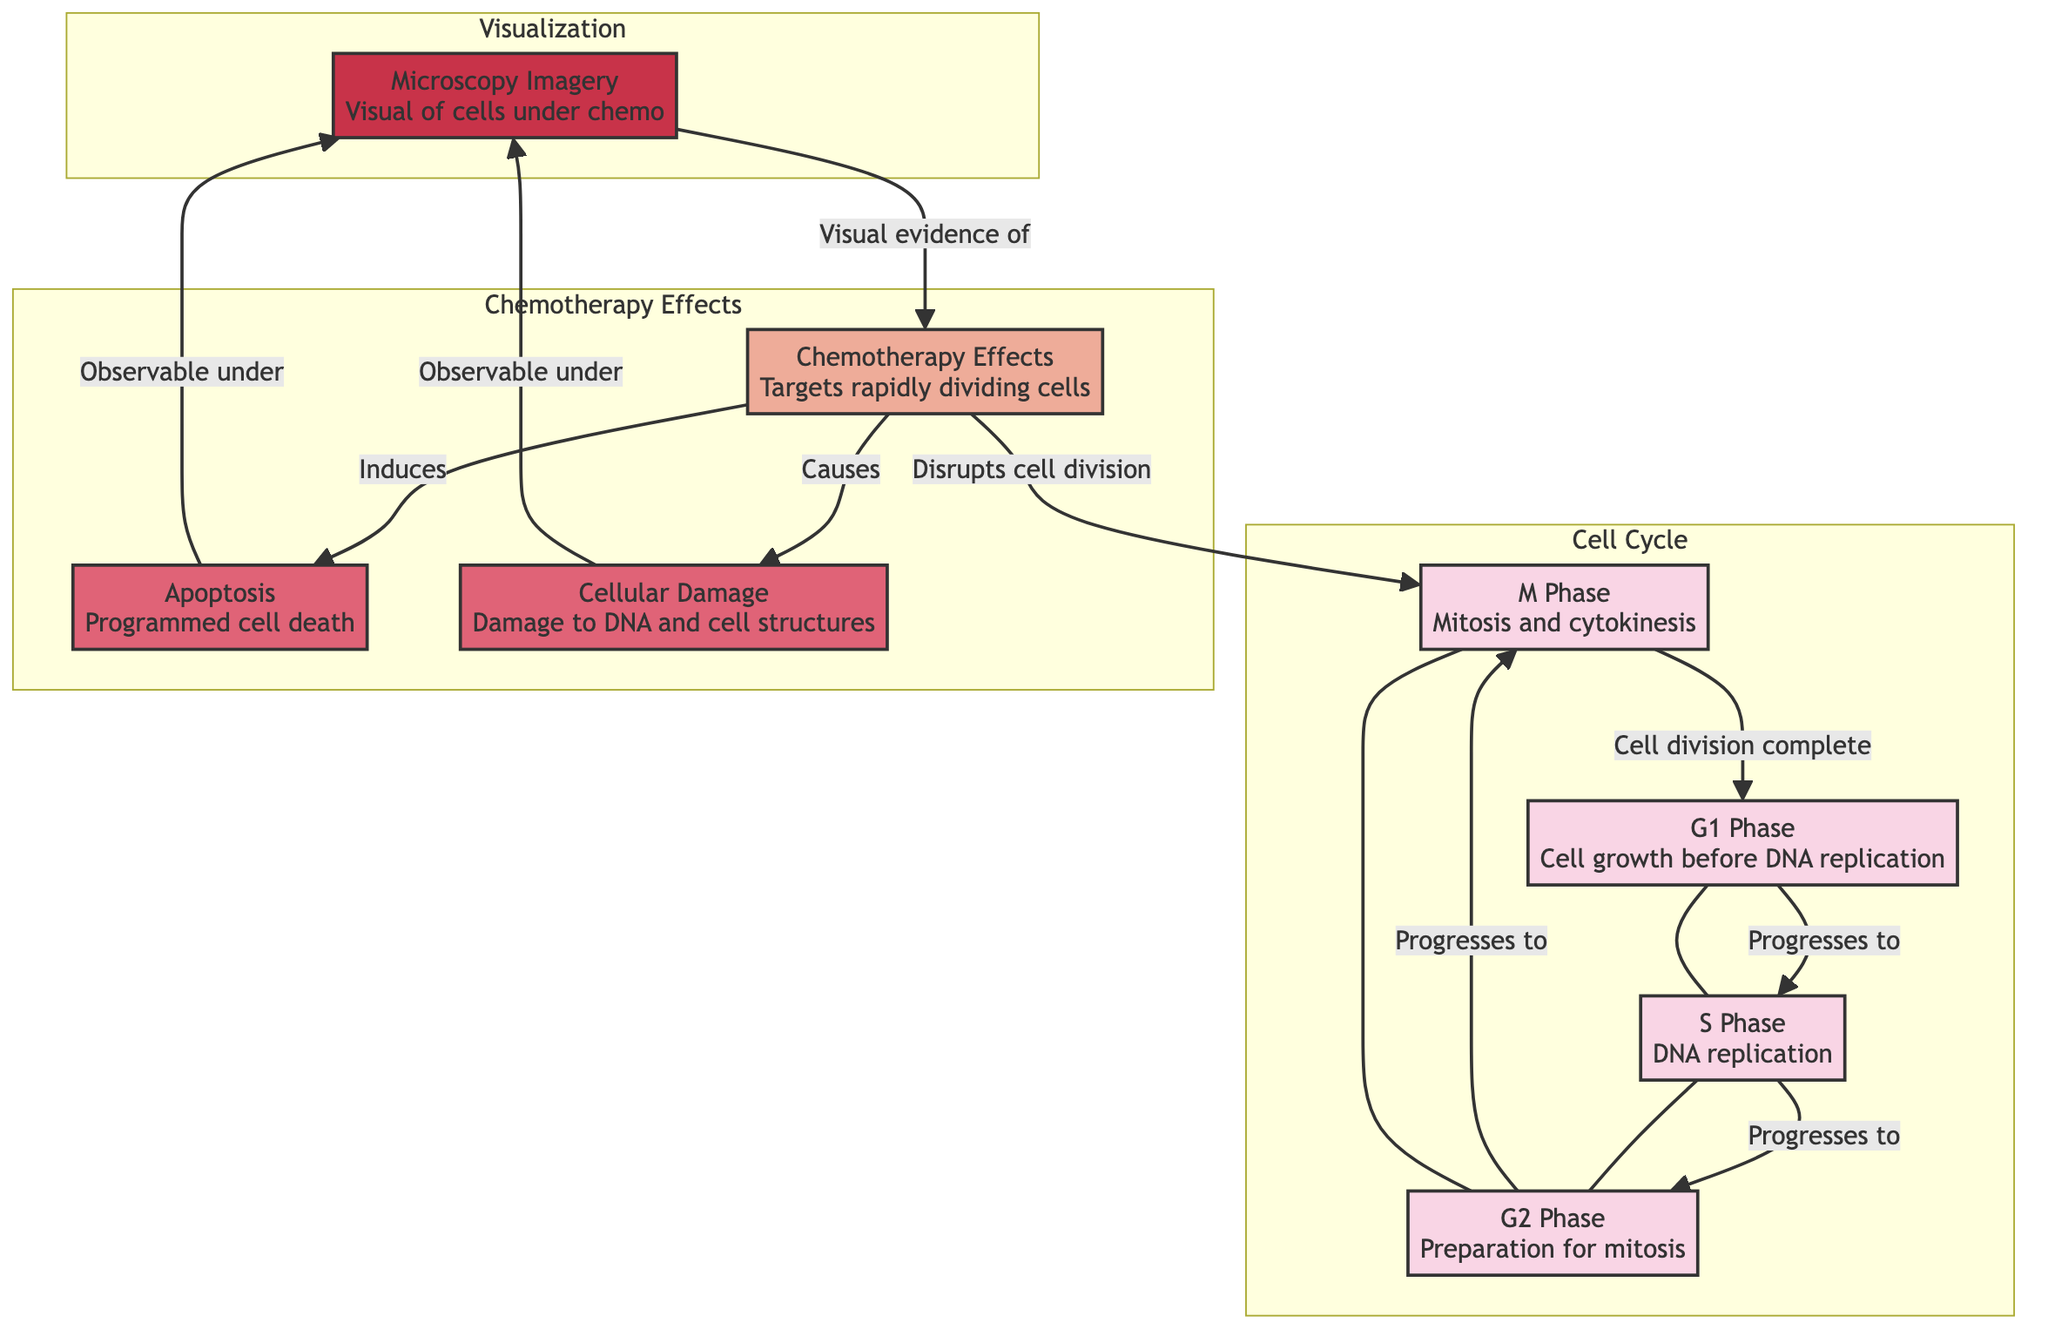What are the phases of the cell cycle depicted in the diagram? The diagram shows four phases of the cell cycle: G1, S, G2, and M. These phases are represented as nodes that are sequentially connected.
Answer: G1, S, G2, M Which phase follows the S phase in the cell cycle? According to the flow of the diagram, after the S phase, the next phase is the G2 phase, as indicated by the directional arrow connecting these two nodes.
Answer: G2 How many effects of chemotherapy are illustrated in the diagram? There are three chemotherapy effects depicted: apoptosis, cellular damage, and disruption of cell division. These are separate nodes listed under the section for Chemotherapy Effects.
Answer: 3 What type of cellular change is induced by chemotherapy according to the diagram? The diagram indicates that chemotherapy induces apoptosis, which is a programmed cell death, as shown in the connection from the chemotherapy node to the apoptosis node.
Answer: Apoptosis How does chemotherapy affect the M phase of the cell cycle? The diagram specifies that chemotherapy disrupts cell division during the M phase, which is shown by the arrow leading from chemotherapy to the M phase. This suggests that it impacts the process of mitosis.
Answer: Disrupts cell division What visual evidence is obtained from microscopy imagery related to chemotherapy? The microscopy imagery node shows that both apoptosis and cellular damage can be observed under a microscope as a result of chemotherapy, as indicated by the arrows leading from these nodes to the micro node.
Answer: Observable under micro Which node represents the phase where DNA replication occurs? In the diagram, the S phase is where DNA replication takes place, as denoted by its description in the node.
Answer: S Phase What is the primary target of chemotherapy in the context of the cell cycle? Chemotherapy primarily targets rapidly dividing cells, as detailed in the chemotherapy effects node, indicating that it disruptively interacts with cells that are consistently in the cycle of division.
Answer: Rapidly dividing cells 